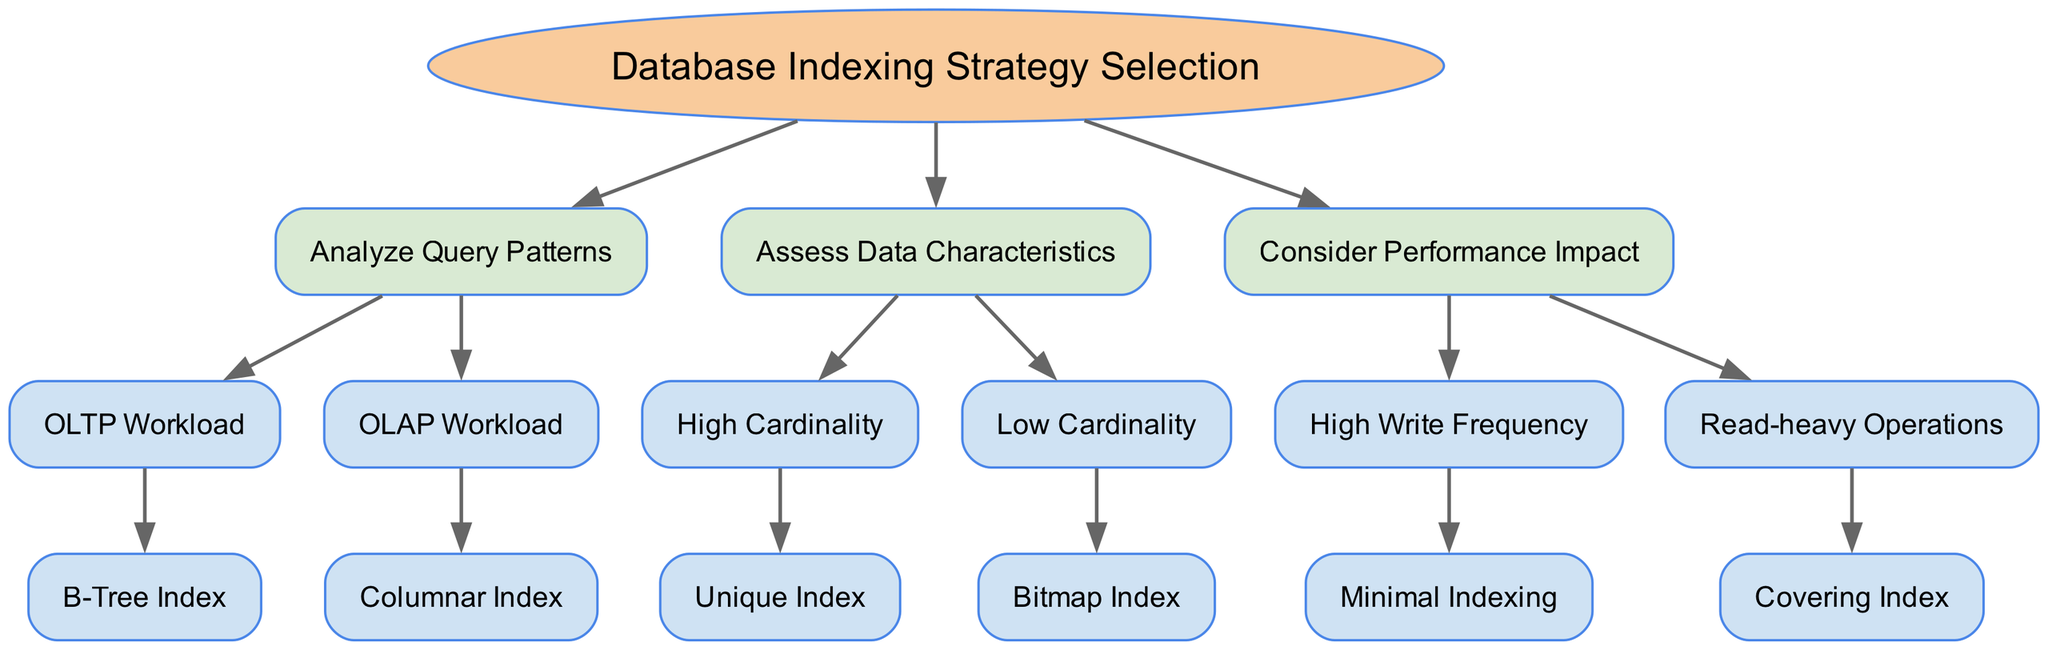What is the root of the diagram? The root of the diagram is "Database Indexing Strategy Selection," which serves as the starting point for the decision-making process regarding indexing strategies.
Answer: Database Indexing Strategy Selection How many main categories are there in the diagram? The diagram has three main categories, which are "Analyze Query Patterns," "Assess Data Characteristics," and "Consider Performance Impact."
Answer: 3 What indexing strategy is recommended for an OLTP workload? For an OLTP workload, the recommended indexing strategy is a B-Tree Index, which is specifically indicated as the outcome of following that path in the decision tree.
Answer: B-Tree Index What indexing strategy should be chosen for high cardinality data? The diagram suggests a Unique Index as the optimal strategy for high cardinality data, leading to effective indexing for such datasets.
Answer: Unique Index Which option is advised for read-heavy operations? The diagram indicates a Covering Index as the recommended choice for scenarios characterized by read-heavy operations to optimize performance.
Answer: Covering Index What action should be taken when there is high write frequency? The recommended action in the diagram when there is high write frequency is to implement Minimal Indexing, which helps to reduce overhead during write operations.
Answer: Minimal Indexing What type of workload requires a Columnar Index? The diagram specifies that an OLAP workload necessitates a Columnar Index for optimizing query performance in analytical processing.
Answer: Columnar Index What relationship exists between "Assess Data Characteristics" and "High Cardinality"? "High Cardinality" is a child node under "Assess Data Characteristics," indicating that it is one of the factors considered when evaluating data properties for indexing strategies.
Answer: Child node relationship What are the two outcomes of the "Consider Performance Impact" node? The two outcomes from the "Consider Performance Impact" node are "Minimal Indexing" for high write frequency and "Covering Index" for read-heavy operations, showing distinctions based on performance needs.
Answer: Minimal Indexing and Covering Index 